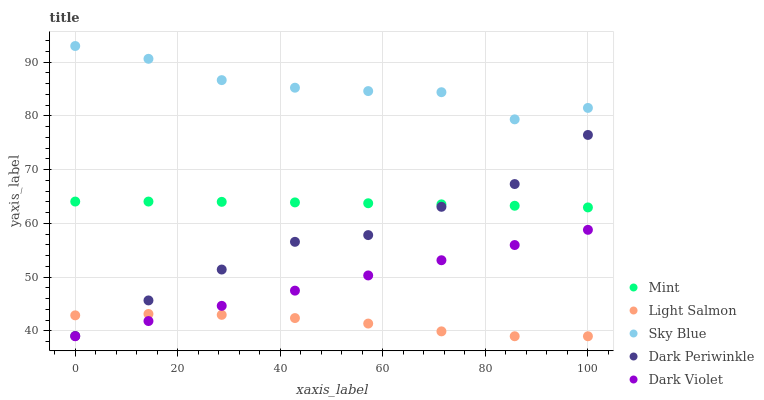Does Light Salmon have the minimum area under the curve?
Answer yes or no. Yes. Does Sky Blue have the maximum area under the curve?
Answer yes or no. Yes. Does Mint have the minimum area under the curve?
Answer yes or no. No. Does Mint have the maximum area under the curve?
Answer yes or no. No. Is Dark Violet the smoothest?
Answer yes or no. Yes. Is Sky Blue the roughest?
Answer yes or no. Yes. Is Light Salmon the smoothest?
Answer yes or no. No. Is Light Salmon the roughest?
Answer yes or no. No. Does Light Salmon have the lowest value?
Answer yes or no. Yes. Does Mint have the lowest value?
Answer yes or no. No. Does Sky Blue have the highest value?
Answer yes or no. Yes. Does Mint have the highest value?
Answer yes or no. No. Is Mint less than Sky Blue?
Answer yes or no. Yes. Is Sky Blue greater than Dark Periwinkle?
Answer yes or no. Yes. Does Light Salmon intersect Dark Violet?
Answer yes or no. Yes. Is Light Salmon less than Dark Violet?
Answer yes or no. No. Is Light Salmon greater than Dark Violet?
Answer yes or no. No. Does Mint intersect Sky Blue?
Answer yes or no. No. 